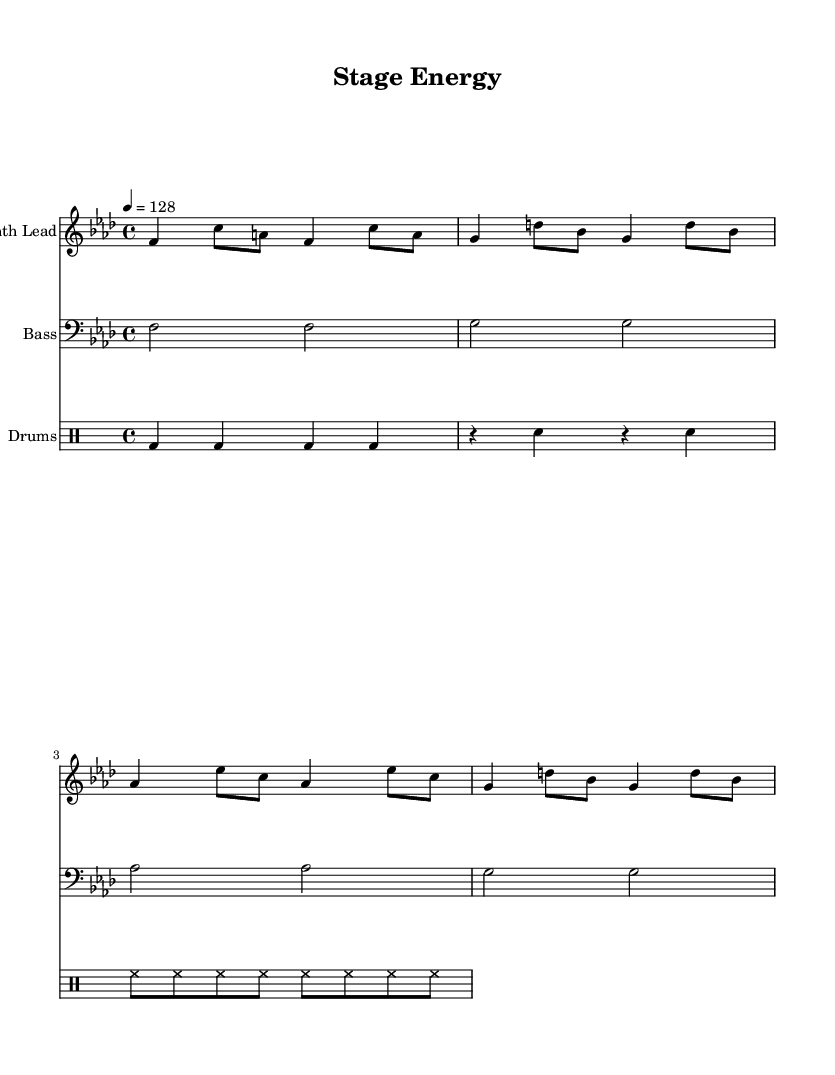What is the key signature of this music? The key signature is F minor, which has four flats (B, E, A, D) indicated at the beginning of the staff.
Answer: F minor What is the time signature of this music? The time signature is displayed after the clef and shows a 4 over 4, which indicates four beats in each measure.
Answer: 4/4 What is the tempo marking for this piece? The tempo marking states "4 = 128," indicating that there are 128 beats per minute, which is a moderately fast tempo typical for EDM tracks.
Answer: 128 How many measures are in the Synth Lead section? Counting the notes and the measure lines in the Synth Lead part shows there are four measures in total.
Answer: 4 What instrument part uses a bass clef? The bass part is written on a staff that uses a bass clef to represent lower notes. This identifies it as the bass instrument.
Answer: Bass Which type of drum is indicated in the drum part? The notation shows "bd," which stands for bass drum, meaning this specific part includes beats played on a bass drum.
Answer: Bass drum What type of musical piece is this score classified as? Given the elements like synthesizers, bass, and electronic drums in the score, it can be classified as an energetic EDM track designed for pre-show warm-ups.
Answer: Energetic EDM 